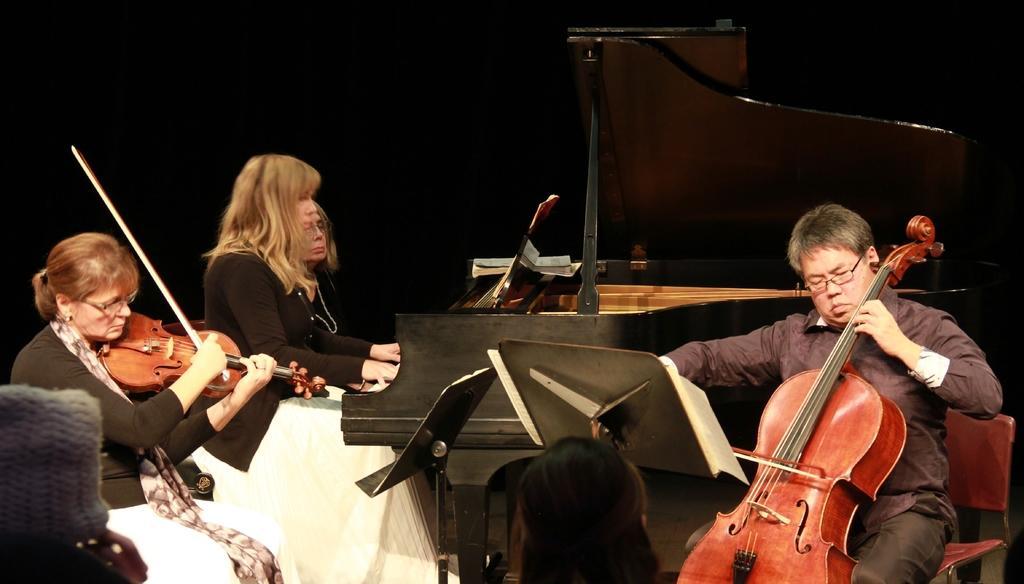How would you summarize this image in a sentence or two? In this image I can see few people were three of them are women and one is a man. I can also see all of them are holding musical instruments. 